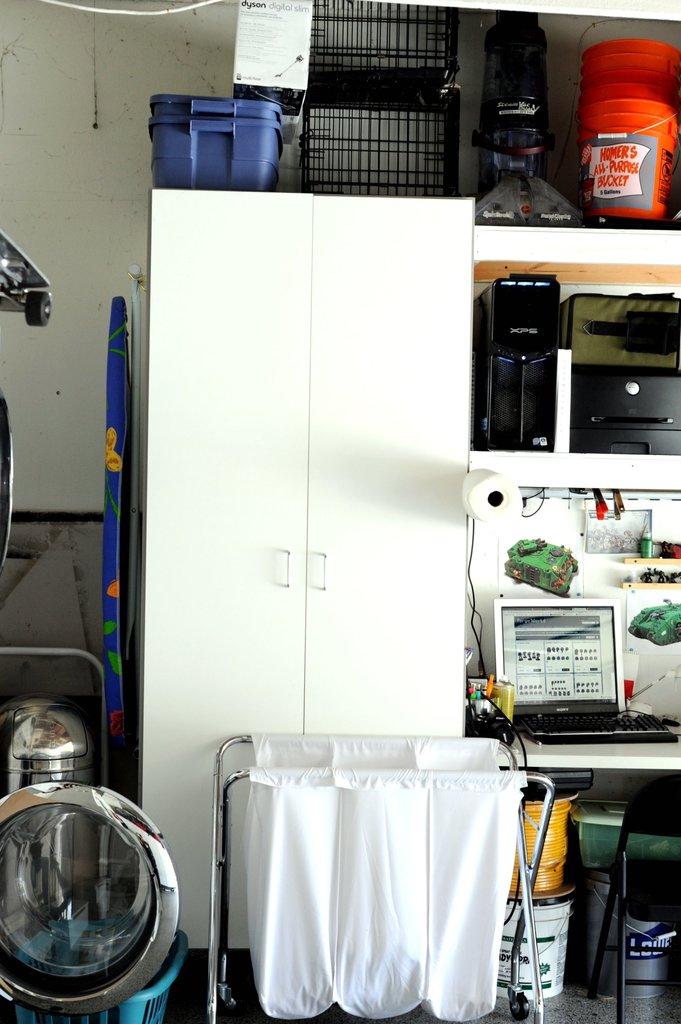What does it say on the orange bucket?
Your response must be concise. Homer's all purpose bucket. 